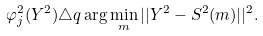<formula> <loc_0><loc_0><loc_500><loc_500>\varphi _ { j } ^ { 2 } ( Y ^ { 2 } ) & \triangle q \arg \min _ { m } | | Y ^ { 2 } - S ^ { 2 } ( m ) | | ^ { 2 } .</formula> 